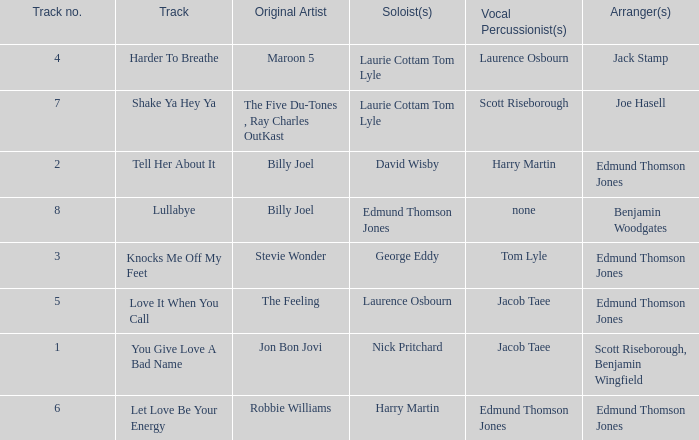Could you help me parse every detail presented in this table? {'header': ['Track no.', 'Track', 'Original Artist', 'Soloist(s)', 'Vocal Percussionist(s)', 'Arranger(s)'], 'rows': [['4', 'Harder To Breathe', 'Maroon 5', 'Laurie Cottam Tom Lyle', 'Laurence Osbourn', 'Jack Stamp'], ['7', 'Shake Ya Hey Ya', 'The Five Du-Tones , Ray Charles OutKast', 'Laurie Cottam Tom Lyle', 'Scott Riseborough', 'Joe Hasell'], ['2', 'Tell Her About It', 'Billy Joel', 'David Wisby', 'Harry Martin', 'Edmund Thomson Jones'], ['8', 'Lullabye', 'Billy Joel', 'Edmund Thomson Jones', 'none', 'Benjamin Woodgates'], ['3', 'Knocks Me Off My Feet', 'Stevie Wonder', 'George Eddy', 'Tom Lyle', 'Edmund Thomson Jones'], ['5', 'Love It When You Call', 'The Feeling', 'Laurence Osbourn', 'Jacob Taee', 'Edmund Thomson Jones'], ['1', 'You Give Love A Bad Name', 'Jon Bon Jovi', 'Nick Pritchard', 'Jacob Taee', 'Scott Riseborough, Benjamin Wingfield'], ['6', 'Let Love Be Your Energy', 'Robbie Williams', 'Harry Martin', 'Edmund Thomson Jones', 'Edmund Thomson Jones']]} How many tracks have the title let love be your energy? 1.0. 